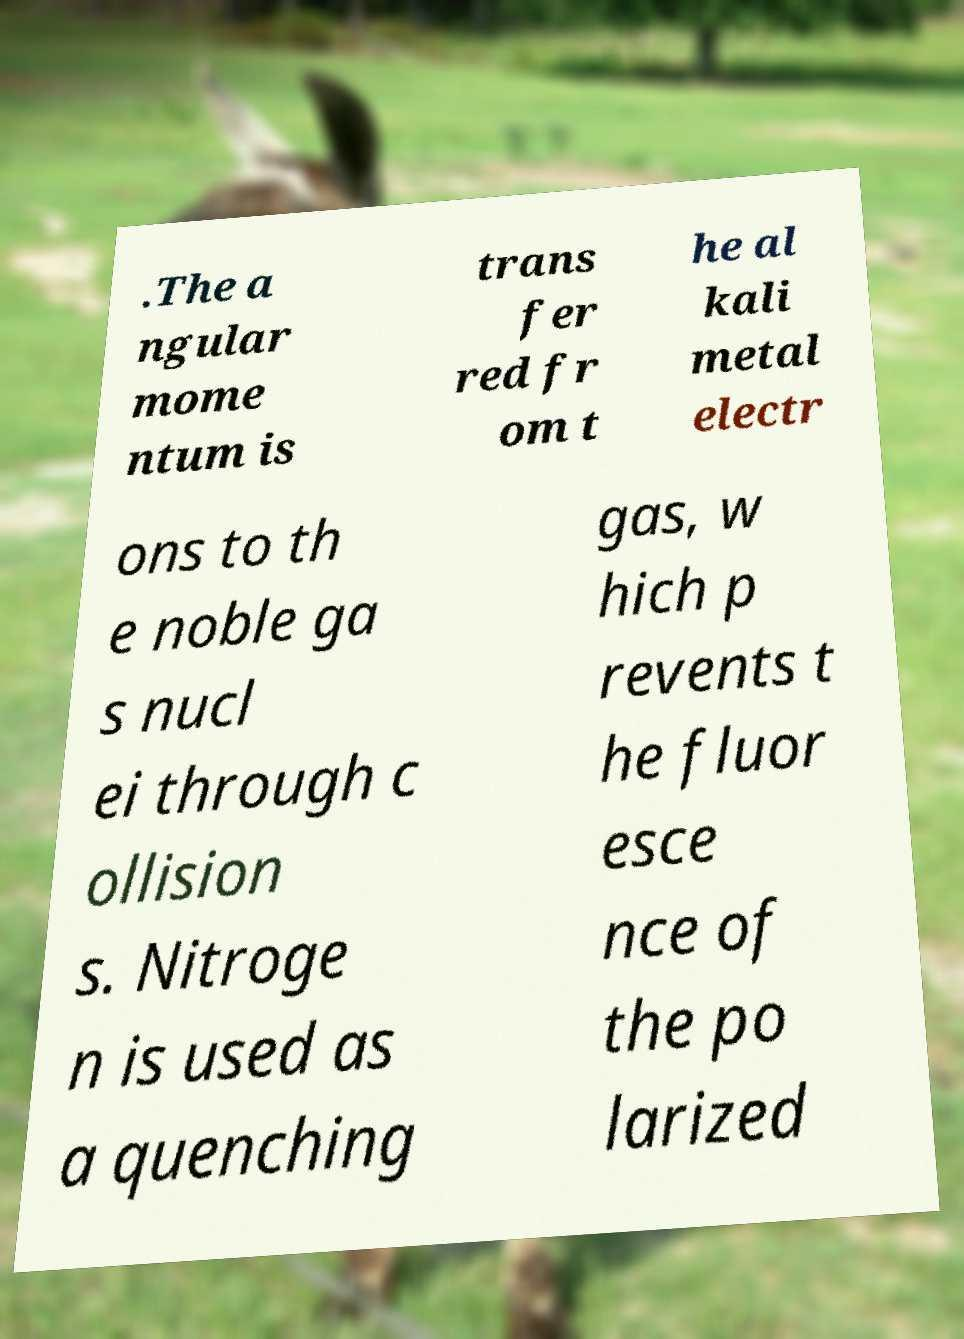Can you accurately transcribe the text from the provided image for me? .The a ngular mome ntum is trans fer red fr om t he al kali metal electr ons to th e noble ga s nucl ei through c ollision s. Nitroge n is used as a quenching gas, w hich p revents t he fluor esce nce of the po larized 